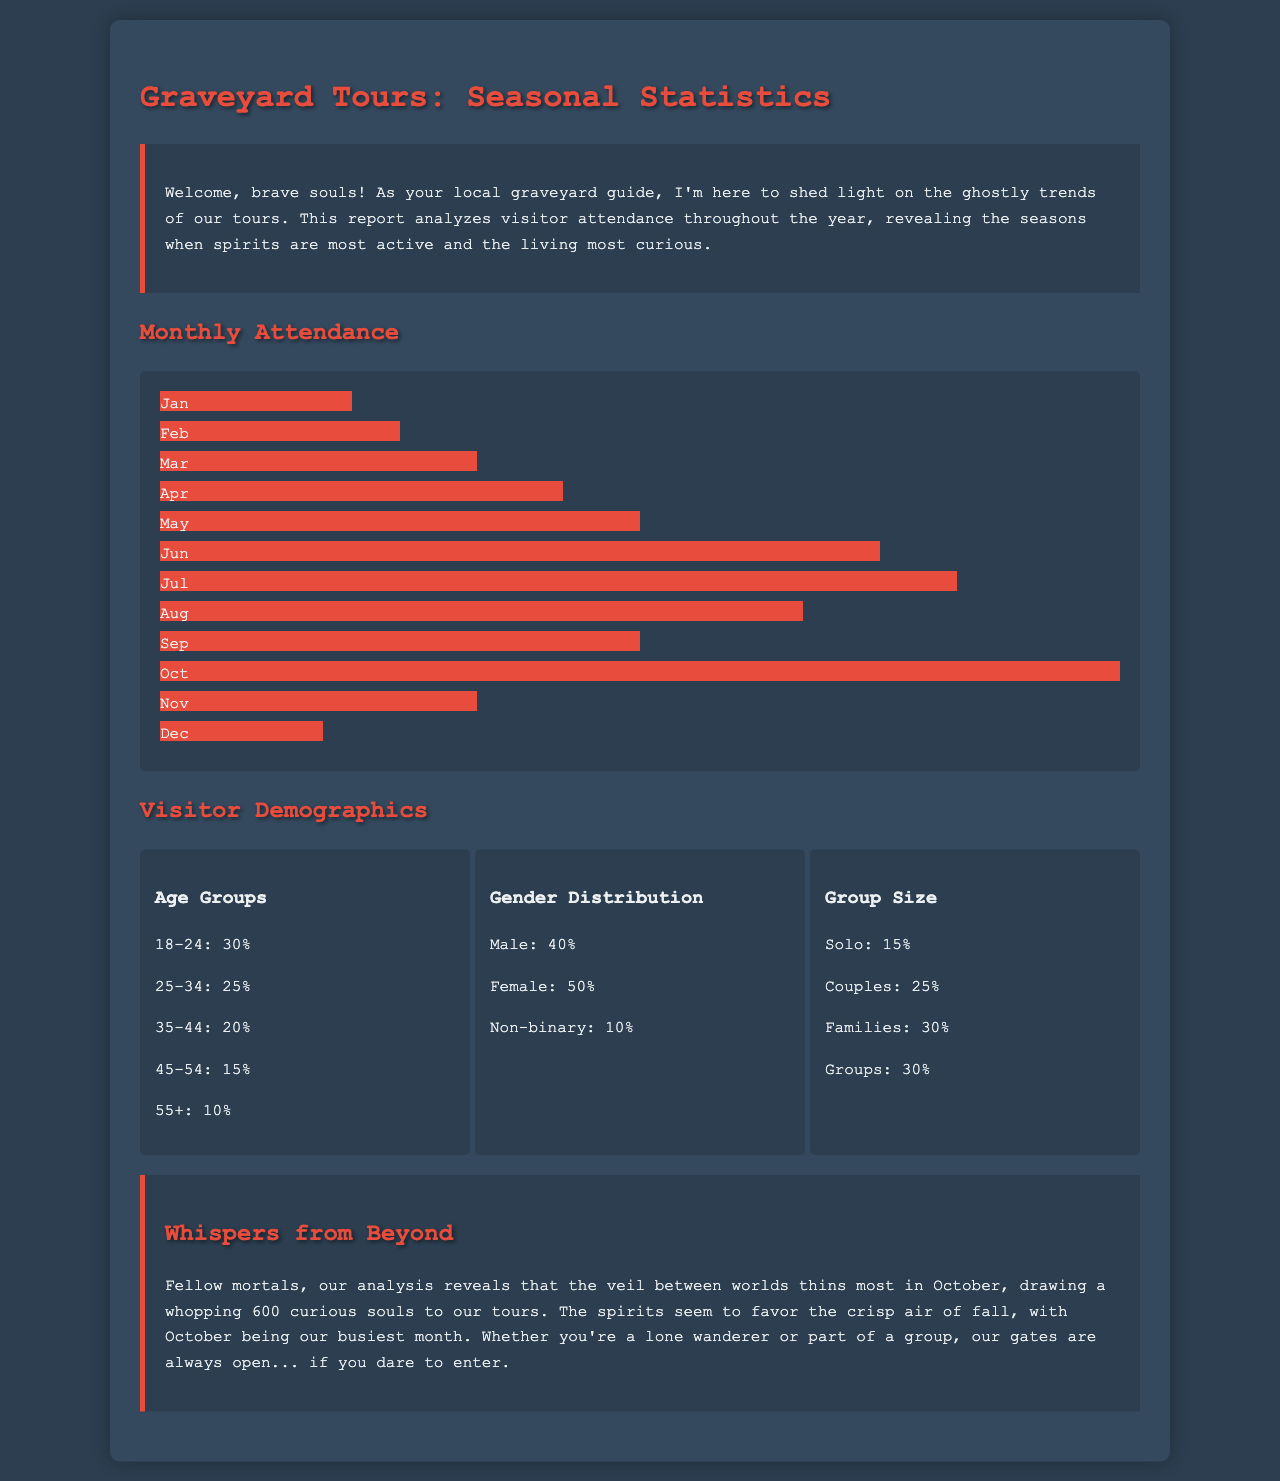What is the peak month for visitor attendance? The report indicates that October has the highest number of visitors, with 600 attendees.
Answer: October How many visitors were recorded in June? The attendance for June is stated as 450 visitors.
Answer: 450 What percentage of visitors are aged 25-34? The demographic data shows that 25% of visitors fall in the age group of 25-34.
Answer: 25% Which gender has a higher percentage among visitors? The document shows that 50% of visitors are female, which is higher than the male percentage of 40%.
Answer: Female What is the group size percentage for families? According to the demographics section, 30% of visitors are families.
Answer: 30% How many visitors attended in January? The number of visitors in January is recorded as 120.
Answer: 120 What is the total percentage representation of visitors aged 18-24 and 25-34 combined? The combined percentage of these age groups is 30% + 25% = 55%.
Answer: 55% What percentage of visitors are in the solo category based on group size? The report states that 15% of visitors are categorized as solo.
Answer: 15% Which month shows the lowest visitor attendance? The report indicates that December has the lowest attendance with 100 visitors.
Answer: December 